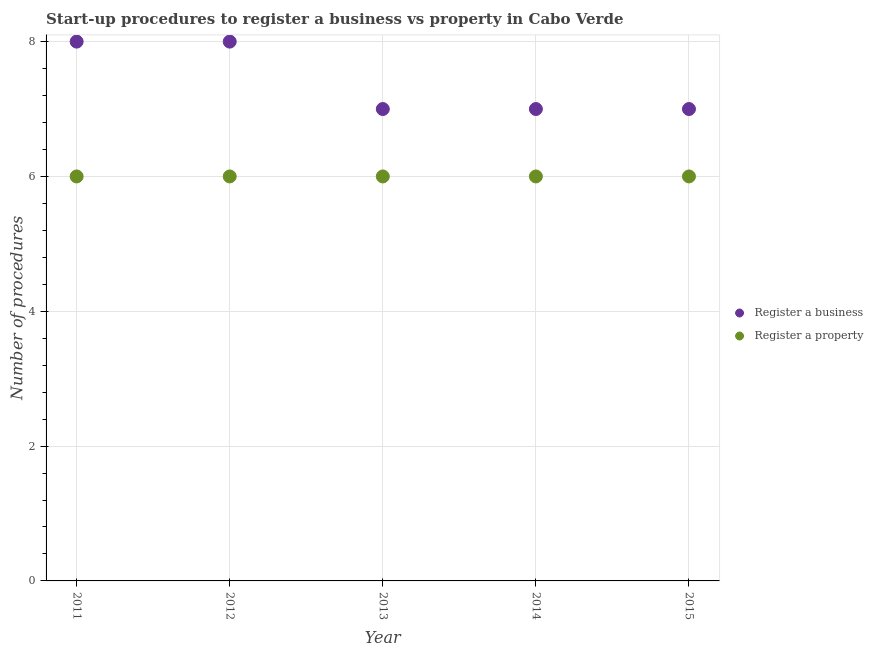What is the number of procedures to register a property in 2015?
Your answer should be very brief. 6. Across all years, what is the minimum number of procedures to register a property?
Provide a succinct answer. 6. In which year was the number of procedures to register a property maximum?
Give a very brief answer. 2011. In which year was the number of procedures to register a property minimum?
Provide a succinct answer. 2011. What is the total number of procedures to register a business in the graph?
Give a very brief answer. 37. What is the difference between the number of procedures to register a business in 2011 and the number of procedures to register a property in 2014?
Keep it short and to the point. 2. In the year 2012, what is the difference between the number of procedures to register a business and number of procedures to register a property?
Provide a succinct answer. 2. In how many years, is the number of procedures to register a business greater than 2.8?
Provide a succinct answer. 5. What is the difference between the highest and the second highest number of procedures to register a property?
Offer a terse response. 0. What is the difference between the highest and the lowest number of procedures to register a business?
Provide a short and direct response. 1. Is the sum of the number of procedures to register a property in 2013 and 2014 greater than the maximum number of procedures to register a business across all years?
Make the answer very short. Yes. Is the number of procedures to register a property strictly greater than the number of procedures to register a business over the years?
Offer a very short reply. No. Are the values on the major ticks of Y-axis written in scientific E-notation?
Keep it short and to the point. No. Where does the legend appear in the graph?
Your answer should be very brief. Center right. How many legend labels are there?
Give a very brief answer. 2. What is the title of the graph?
Offer a very short reply. Start-up procedures to register a business vs property in Cabo Verde. What is the label or title of the Y-axis?
Offer a terse response. Number of procedures. What is the Number of procedures in Register a property in 2011?
Your response must be concise. 6. What is the Number of procedures of Register a business in 2012?
Your answer should be compact. 8. What is the Number of procedures in Register a property in 2012?
Provide a short and direct response. 6. What is the Number of procedures of Register a business in 2013?
Offer a terse response. 7. What is the Number of procedures in Register a property in 2013?
Provide a short and direct response. 6. What is the Number of procedures of Register a business in 2014?
Ensure brevity in your answer.  7. What is the Number of procedures of Register a property in 2014?
Offer a very short reply. 6. What is the Number of procedures in Register a business in 2015?
Your answer should be compact. 7. What is the Number of procedures in Register a property in 2015?
Ensure brevity in your answer.  6. Across all years, what is the maximum Number of procedures in Register a business?
Make the answer very short. 8. What is the difference between the Number of procedures of Register a property in 2011 and that in 2013?
Give a very brief answer. 0. What is the difference between the Number of procedures of Register a business in 2011 and that in 2015?
Your answer should be compact. 1. What is the difference between the Number of procedures in Register a property in 2011 and that in 2015?
Your response must be concise. 0. What is the difference between the Number of procedures in Register a business in 2012 and that in 2013?
Give a very brief answer. 1. What is the difference between the Number of procedures in Register a business in 2012 and that in 2014?
Ensure brevity in your answer.  1. What is the difference between the Number of procedures of Register a property in 2012 and that in 2014?
Keep it short and to the point. 0. What is the difference between the Number of procedures in Register a property in 2012 and that in 2015?
Your answer should be very brief. 0. What is the difference between the Number of procedures in Register a property in 2014 and that in 2015?
Your answer should be compact. 0. What is the difference between the Number of procedures of Register a business in 2011 and the Number of procedures of Register a property in 2013?
Provide a succinct answer. 2. What is the difference between the Number of procedures of Register a business in 2011 and the Number of procedures of Register a property in 2014?
Your answer should be very brief. 2. What is the difference between the Number of procedures in Register a business in 2012 and the Number of procedures in Register a property in 2013?
Ensure brevity in your answer.  2. What is the difference between the Number of procedures of Register a business in 2012 and the Number of procedures of Register a property in 2014?
Your answer should be compact. 2. What is the difference between the Number of procedures of Register a business in 2012 and the Number of procedures of Register a property in 2015?
Offer a very short reply. 2. What is the difference between the Number of procedures of Register a business in 2013 and the Number of procedures of Register a property in 2014?
Make the answer very short. 1. What is the difference between the Number of procedures of Register a business in 2013 and the Number of procedures of Register a property in 2015?
Give a very brief answer. 1. What is the difference between the Number of procedures in Register a business in 2014 and the Number of procedures in Register a property in 2015?
Ensure brevity in your answer.  1. What is the average Number of procedures of Register a property per year?
Ensure brevity in your answer.  6. In the year 2011, what is the difference between the Number of procedures of Register a business and Number of procedures of Register a property?
Make the answer very short. 2. What is the ratio of the Number of procedures in Register a business in 2011 to that in 2012?
Make the answer very short. 1. What is the ratio of the Number of procedures of Register a property in 2011 to that in 2013?
Your answer should be very brief. 1. What is the ratio of the Number of procedures of Register a property in 2011 to that in 2014?
Offer a very short reply. 1. What is the ratio of the Number of procedures in Register a business in 2012 to that in 2014?
Your answer should be very brief. 1.14. What is the ratio of the Number of procedures of Register a property in 2012 to that in 2014?
Provide a short and direct response. 1. What is the ratio of the Number of procedures of Register a business in 2012 to that in 2015?
Provide a short and direct response. 1.14. What is the ratio of the Number of procedures of Register a property in 2012 to that in 2015?
Your answer should be compact. 1. What is the ratio of the Number of procedures of Register a business in 2013 to that in 2014?
Give a very brief answer. 1. What is the ratio of the Number of procedures of Register a property in 2013 to that in 2014?
Your response must be concise. 1. What is the ratio of the Number of procedures of Register a property in 2013 to that in 2015?
Make the answer very short. 1. 